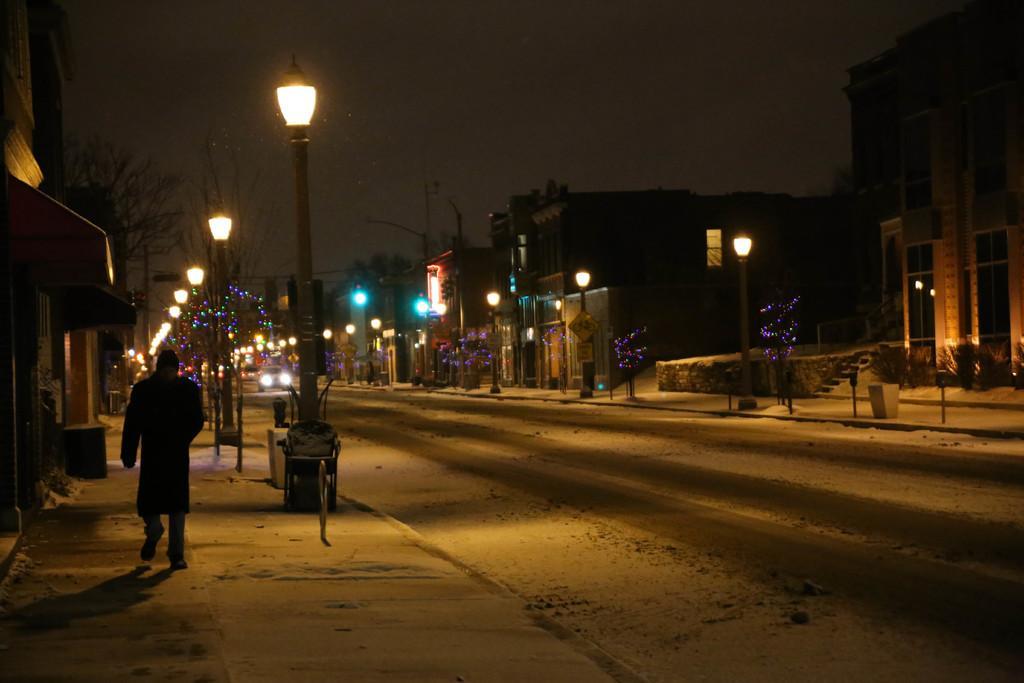Please provide a concise description of this image. In this image in the front there is a man walking. In the center there are light poles and in the background there are buildings, there are light poles, trees and there are vehicles moving on the road. 